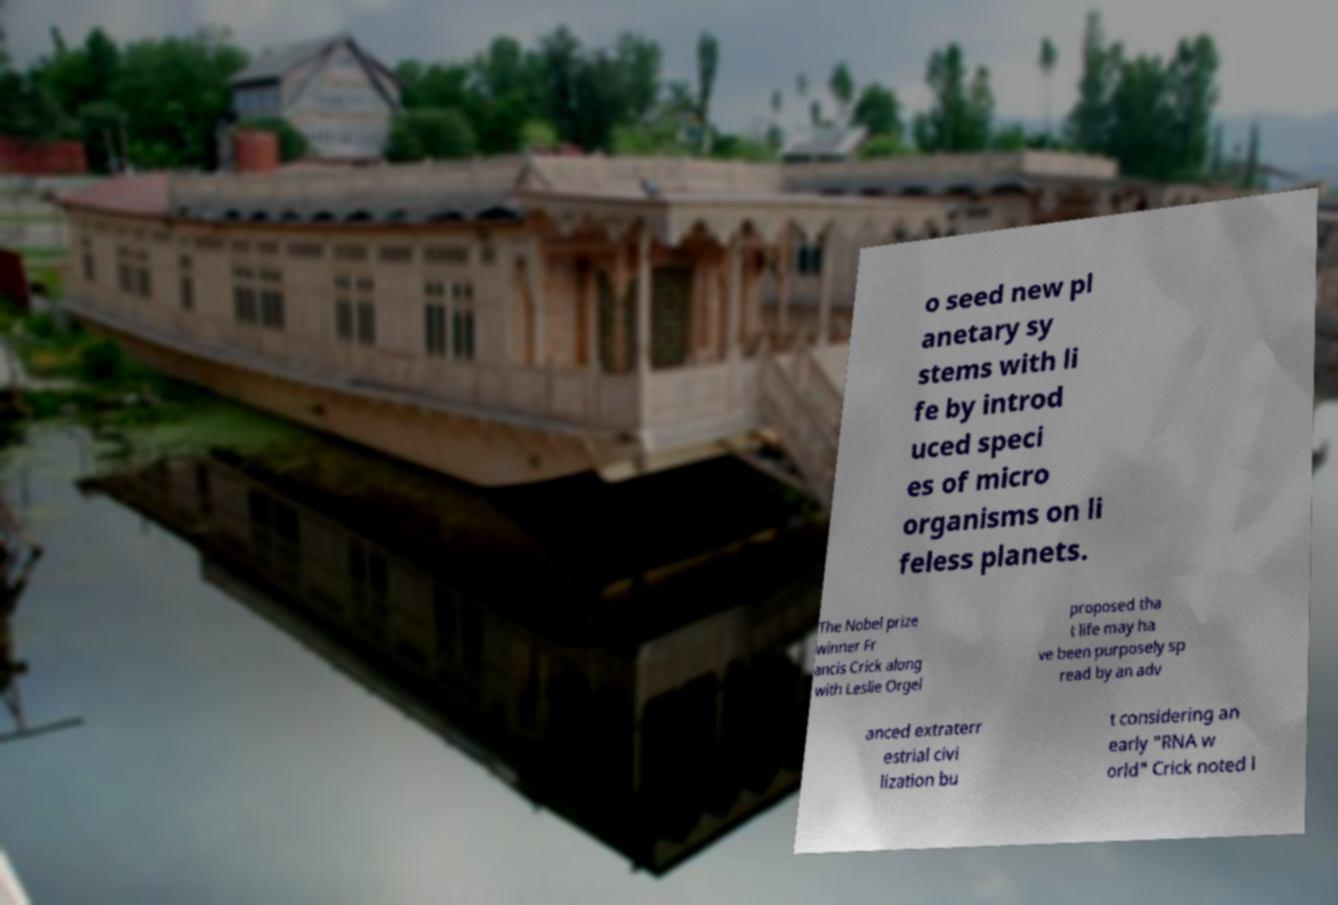For documentation purposes, I need the text within this image transcribed. Could you provide that? o seed new pl anetary sy stems with li fe by introd uced speci es of micro organisms on li feless planets. The Nobel prize winner Fr ancis Crick along with Leslie Orgel proposed tha t life may ha ve been purposely sp read by an adv anced extraterr estrial civi lization bu t considering an early "RNA w orld" Crick noted l 